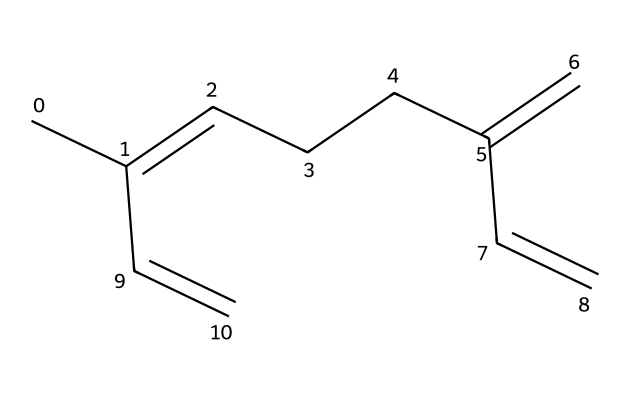What is the name of this chemical? The SMILES representation indicates a hydrocarbon structure with an extensive double bond system, commonly found in essential oils. This specific arrangement corresponds to myrcene, which is well-known and identified by this representation.
Answer: myrcene How many carbon atoms are in myrcene? The SMILES structure can be analyzed, counting each carbon represented, which totals to 10 carbon atoms.
Answer: 10 What type of bonds are present in myrcene? By examining the SMILES, we identify double (C=C) and single bonds in the structure. The presence of multiple double bonds indicates myrcene is an unsaturated hydrocarbon.
Answer: double and single Is myrcene polar or nonpolar? Given that myrcene is a hydrocarbon with no electronegative atoms significantly affecting its overall charge distribution, it can be classified as nonpolar.
Answer: nonpolar How many double bonds does myrcene have? The SMILES structure shows three double bonds present in the molecule, which can be directly counted from the structure representation.
Answer: 3 What type of chemical is myrcene classified as? Myrcene solely consists of carbon and hydrogen atoms, placing it in the category of terpenes, specifically a monoterpene due to its 10 carbon structure.
Answer: terpene 